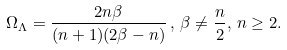<formula> <loc_0><loc_0><loc_500><loc_500>\Omega _ { \Lambda } = \frac { 2 n \beta } { ( n + 1 ) ( 2 \beta - n ) } \, , \, \beta \ne \frac { n } { 2 } , \, n \geq 2 .</formula> 